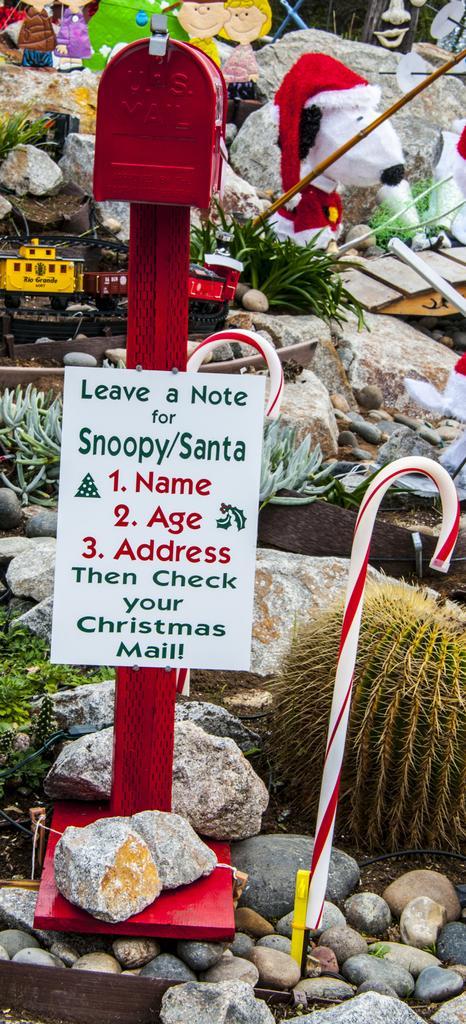Please provide a concise description of this image. In this picture we can see stones, sticks, plants, poster, toys and some objects. 